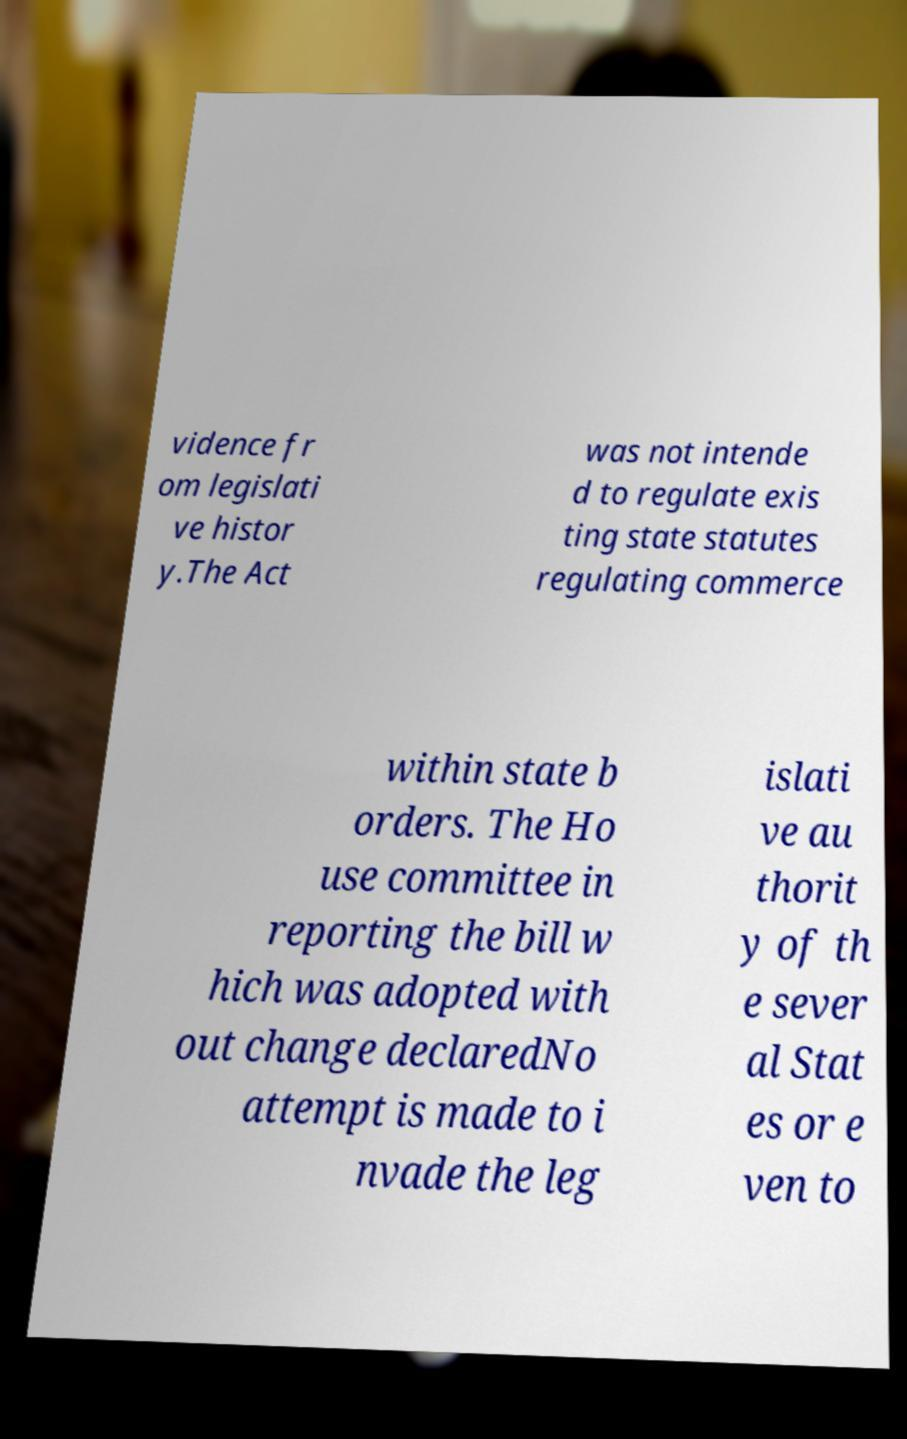What messages or text are displayed in this image? I need them in a readable, typed format. vidence fr om legislati ve histor y.The Act was not intende d to regulate exis ting state statutes regulating commerce within state b orders. The Ho use committee in reporting the bill w hich was adopted with out change declaredNo attempt is made to i nvade the leg islati ve au thorit y of th e sever al Stat es or e ven to 